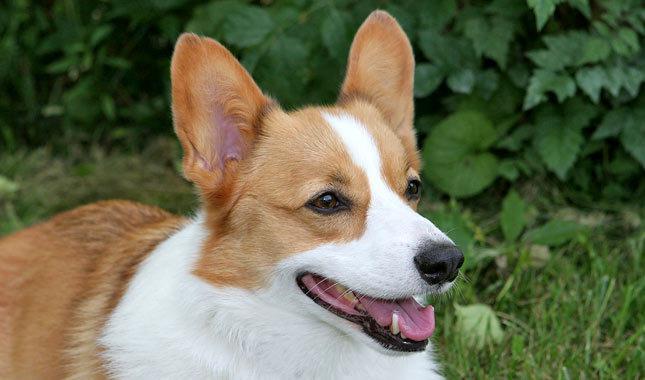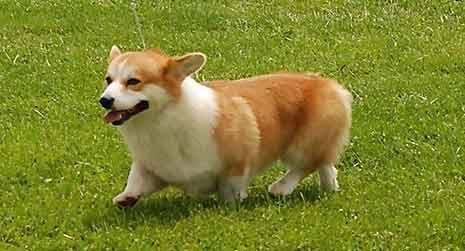The first image is the image on the left, the second image is the image on the right. Evaluate the accuracy of this statement regarding the images: "Each image shows exactly one corgi dog outdoors on grass.". Is it true? Answer yes or no. Yes. The first image is the image on the left, the second image is the image on the right. For the images displayed, is the sentence "In one of the images there is a single corgi sitting on the ground outside." factually correct? Answer yes or no. No. The first image is the image on the left, the second image is the image on the right. For the images shown, is this caption "Neither dog is walking or running." true? Answer yes or no. No. 